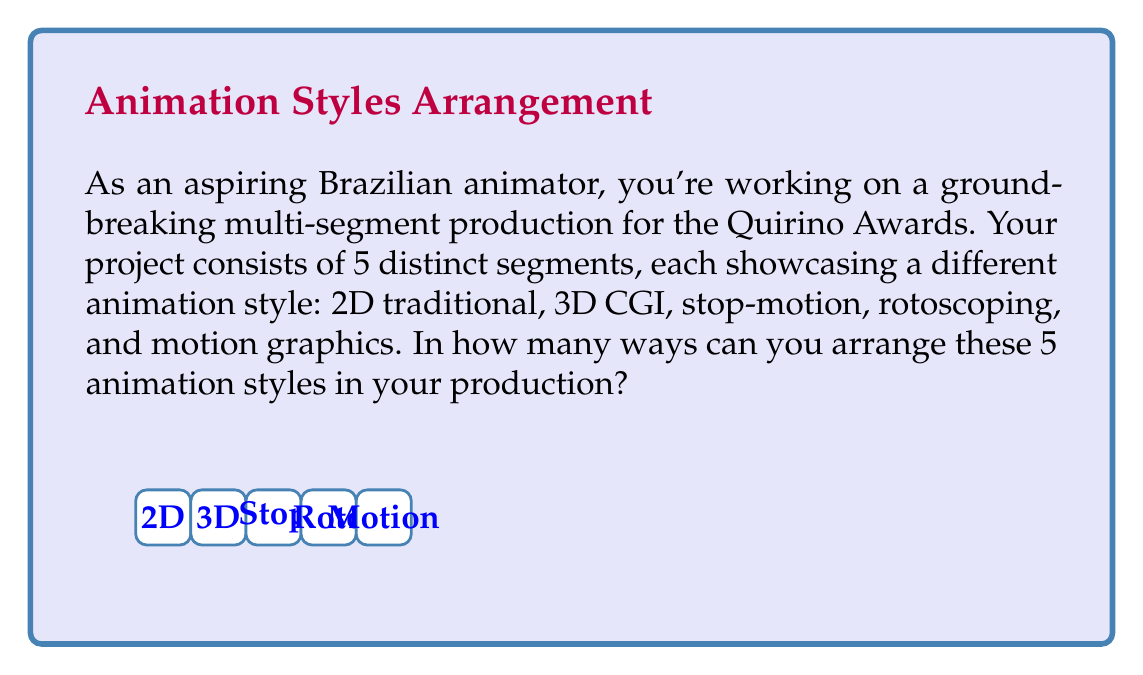What is the answer to this math problem? Let's approach this step-by-step:

1) We have 5 distinct animation styles that need to be arranged in a specific order.

2) This is a classic permutation problem. We need to find the number of ways to arrange 5 distinct objects.

3) For the first position, we have 5 choices of animation styles.

4) For the second position, we have 4 remaining choices.

5) For the third position, we have 3 remaining choices.

6) For the fourth position, we have 2 remaining choices.

7) For the last position, we only have 1 choice left.

8) According to the multiplication principle, we multiply these numbers:

   $$5 \times 4 \times 3 \times 2 \times 1 = 120$$

9) This is also known as 5 factorial, denoted as $5!$

Therefore, there are 120 ways to arrange the 5 animation styles in your multi-segment production.
Answer: $5! = 120$ 